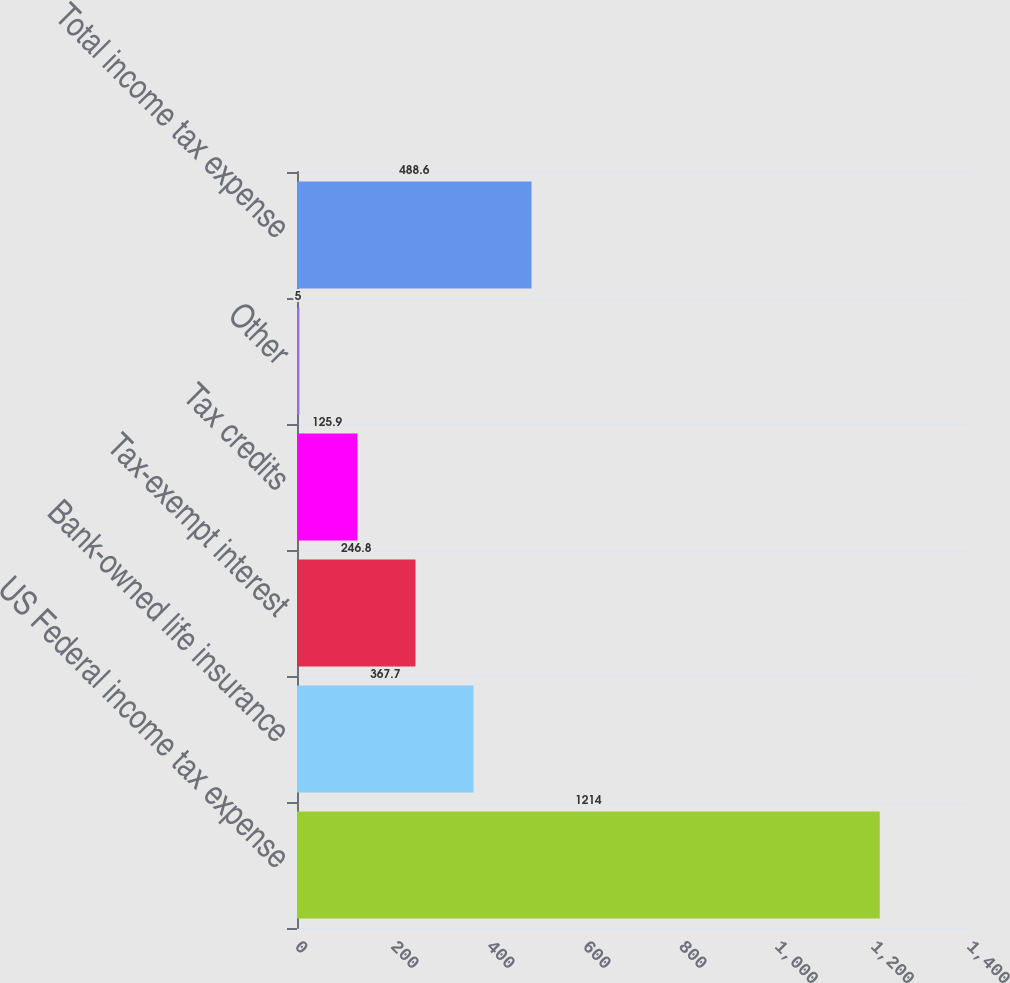Convert chart to OTSL. <chart><loc_0><loc_0><loc_500><loc_500><bar_chart><fcel>US Federal income tax expense<fcel>Bank-owned life insurance<fcel>Tax-exempt interest<fcel>Tax credits<fcel>Other<fcel>Total income tax expense<nl><fcel>1214<fcel>367.7<fcel>246.8<fcel>125.9<fcel>5<fcel>488.6<nl></chart> 